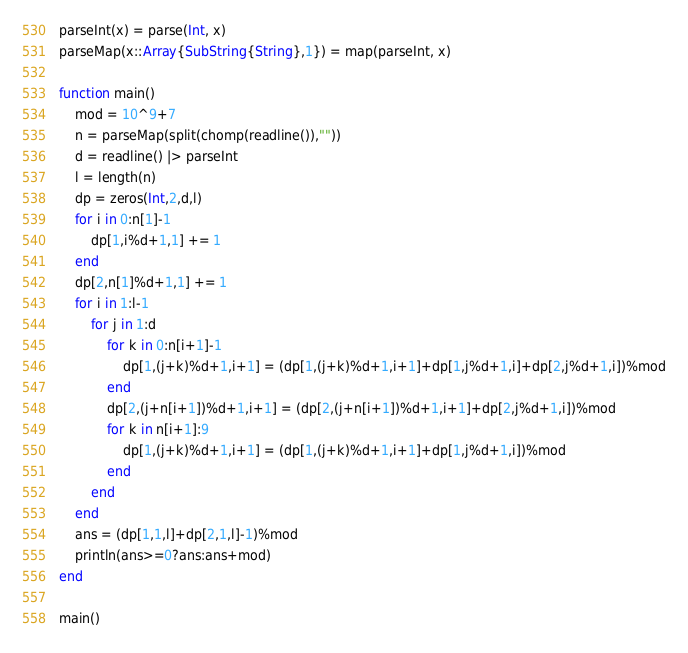<code> <loc_0><loc_0><loc_500><loc_500><_Julia_>parseInt(x) = parse(Int, x)
parseMap(x::Array{SubString{String},1}) = map(parseInt, x)

function main()
	mod = 10^9+7
	n = parseMap(split(chomp(readline()),""))
	d = readline() |> parseInt
	l = length(n)
	dp = zeros(Int,2,d,l)
	for i in 0:n[1]-1
		dp[1,i%d+1,1] += 1
	end
	dp[2,n[1]%d+1,1] += 1
	for i in 1:l-1
		for j in 1:d
			for k in 0:n[i+1]-1
				dp[1,(j+k)%d+1,i+1] = (dp[1,(j+k)%d+1,i+1]+dp[1,j%d+1,i]+dp[2,j%d+1,i])%mod
			end
			dp[2,(j+n[i+1])%d+1,i+1] = (dp[2,(j+n[i+1])%d+1,i+1]+dp[2,j%d+1,i])%mod
			for k in n[i+1]:9
				dp[1,(j+k)%d+1,i+1] = (dp[1,(j+k)%d+1,i+1]+dp[1,j%d+1,i])%mod
			end
		end
	end
	ans = (dp[1,1,l]+dp[2,1,l]-1)%mod
	println(ans>=0?ans:ans+mod)
end

main()</code> 